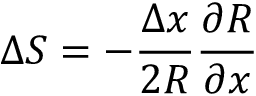Convert formula to latex. <formula><loc_0><loc_0><loc_500><loc_500>\Delta S = - \frac { \Delta x } { 2 R } \frac { \partial R } { \partial x }</formula> 